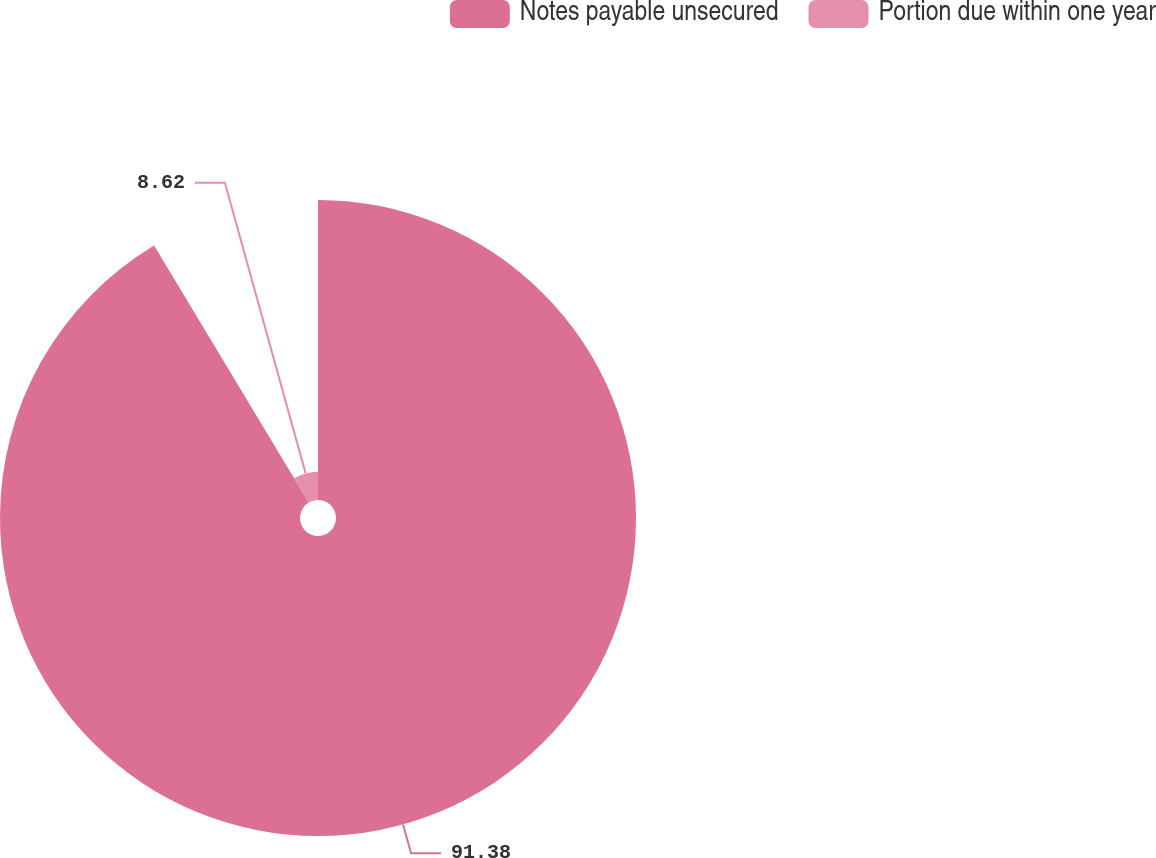Convert chart to OTSL. <chart><loc_0><loc_0><loc_500><loc_500><pie_chart><fcel>Notes payable unsecured<fcel>Portion due within one year<nl><fcel>91.38%<fcel>8.62%<nl></chart> 